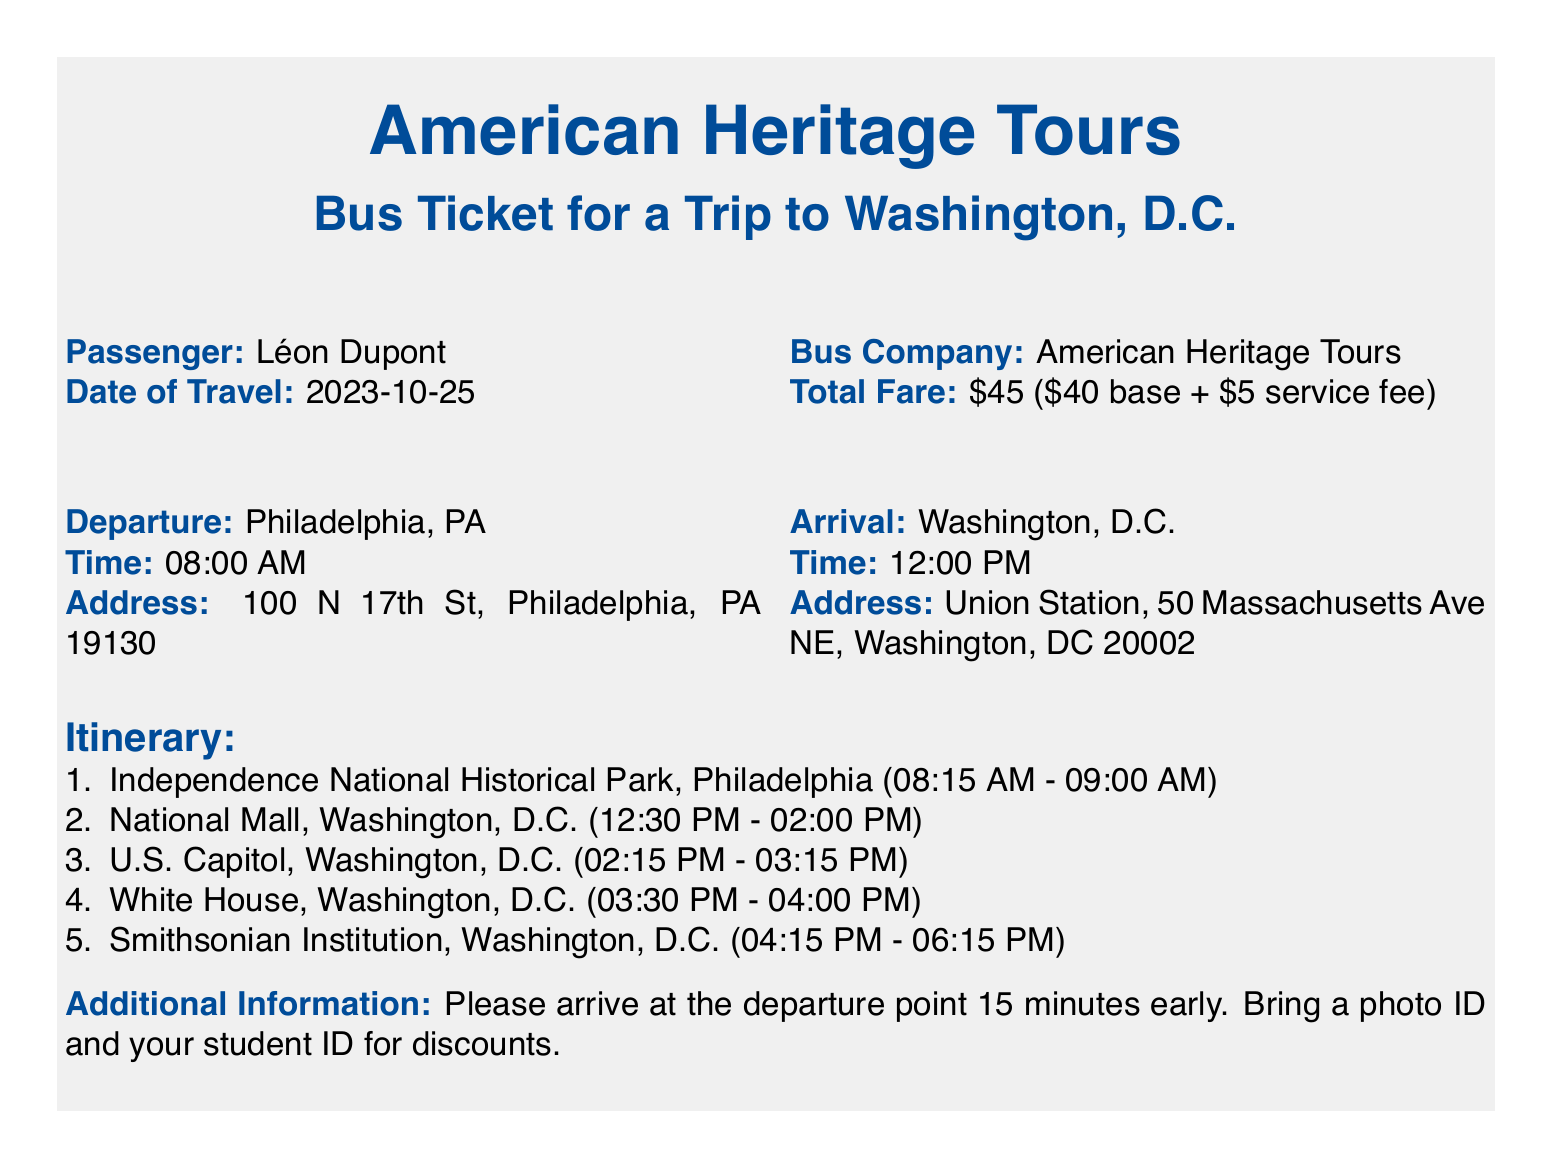What is the name of the passenger? The name of the passenger is specified in the document under 'Passenger'.
Answer: Léon Dupont What is the date of travel? The date of travel is presented in the document under 'Date of Travel'.
Answer: 2023-10-25 What time does the bus depart? The departure time is clearly stated under 'Time' for the departure location.
Answer: 08:00 AM What is the total fare for the trip? The total fare is outlined in the document as the sum of the base fare and service fee.
Answer: $45 Where does the bus arrive? The arrival location is mentioned under 'Arrival'.
Answer: Washington, D.C What landmarks will be visited after arriving in Washington, D.C.? The landmarks visited are listed in the Itinerary section of the document.
Answer: National Mall, U.S. Capitol, White House, Smithsonian Institution How long will the bus stop at Independence National Historical Park? The duration of the stop is included in the itinerary section of the document.
Answer: 45 minutes What should passengers bring for discounts? The document specifies what passengers should carry for discounts in the 'Additional Information' section.
Answer: Photo ID and student ID At what time will the bus arrive in Washington, D.C.? The arrival time is mentioned under 'Time' for the arrival location.
Answer: 12:00 PM 